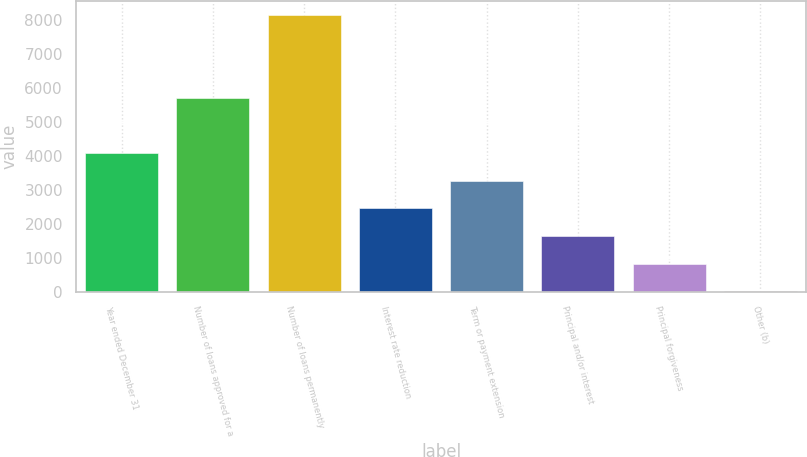Convert chart. <chart><loc_0><loc_0><loc_500><loc_500><bar_chart><fcel>Year ended December 31<fcel>Number of loans approved for a<fcel>Number of loans permanently<fcel>Interest rate reduction<fcel>Term or payment extension<fcel>Principal and/or interest<fcel>Principal forgiveness<fcel>Other (b)<nl><fcel>4088<fcel>5705<fcel>8162<fcel>2458.4<fcel>3273.2<fcel>1643.6<fcel>828.8<fcel>14<nl></chart> 